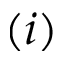<formula> <loc_0><loc_0><loc_500><loc_500>( i )</formula> 